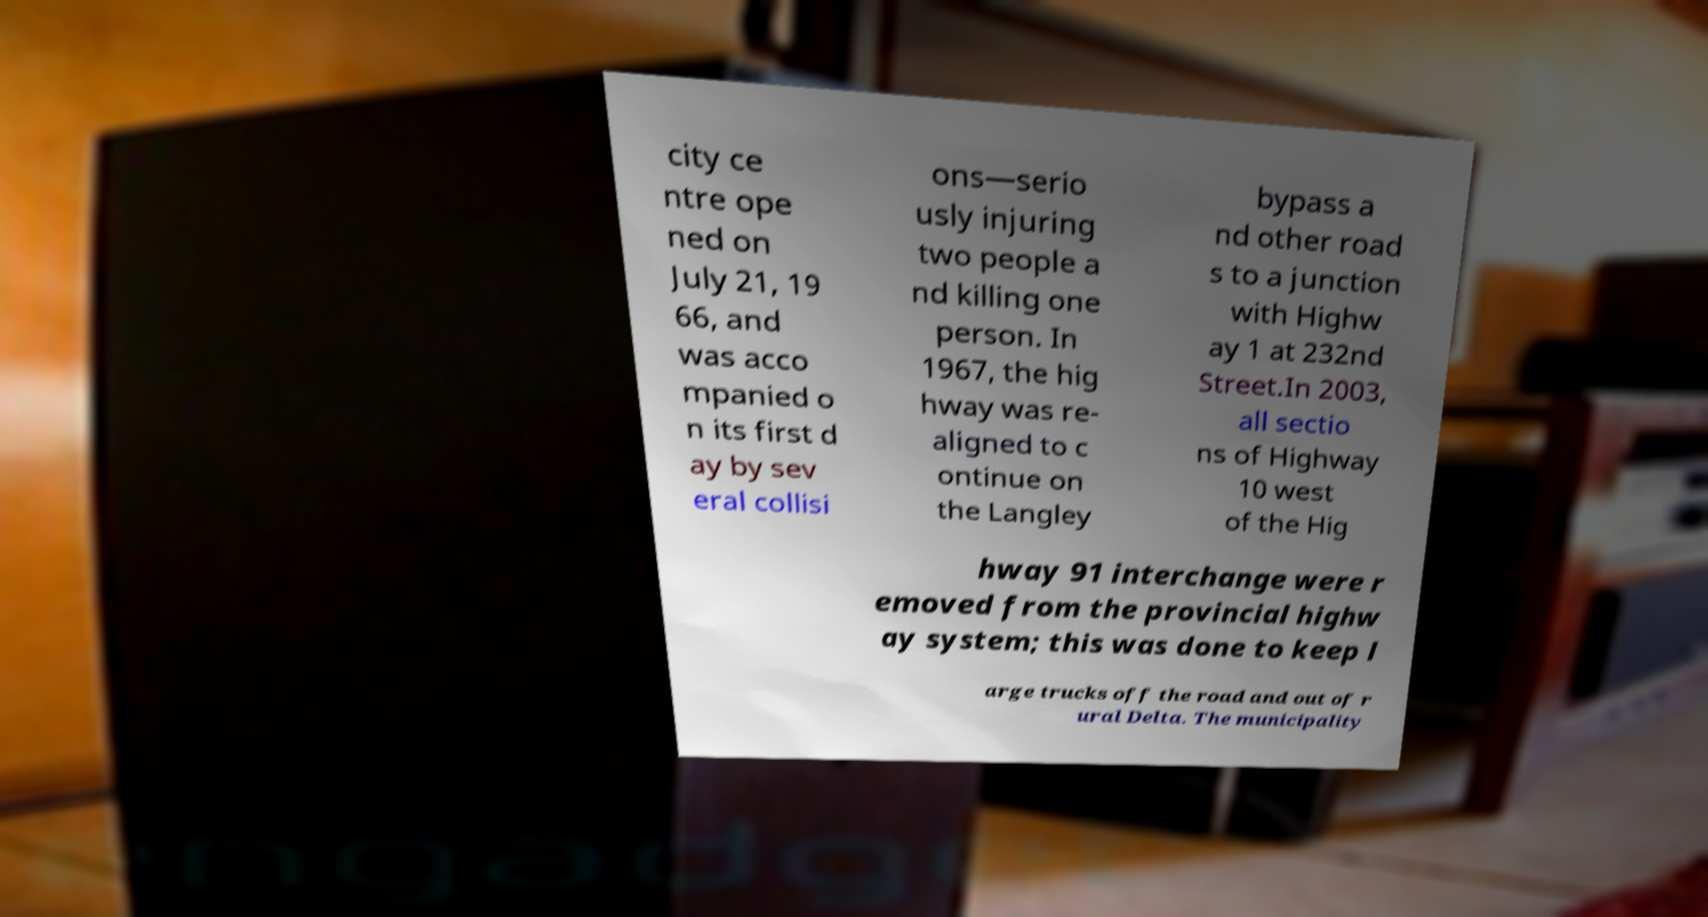There's text embedded in this image that I need extracted. Can you transcribe it verbatim? city ce ntre ope ned on July 21, 19 66, and was acco mpanied o n its first d ay by sev eral collisi ons—serio usly injuring two people a nd killing one person. In 1967, the hig hway was re- aligned to c ontinue on the Langley bypass a nd other road s to a junction with Highw ay 1 at 232nd Street.In 2003, all sectio ns of Highway 10 west of the Hig hway 91 interchange were r emoved from the provincial highw ay system; this was done to keep l arge trucks off the road and out of r ural Delta. The municipality 